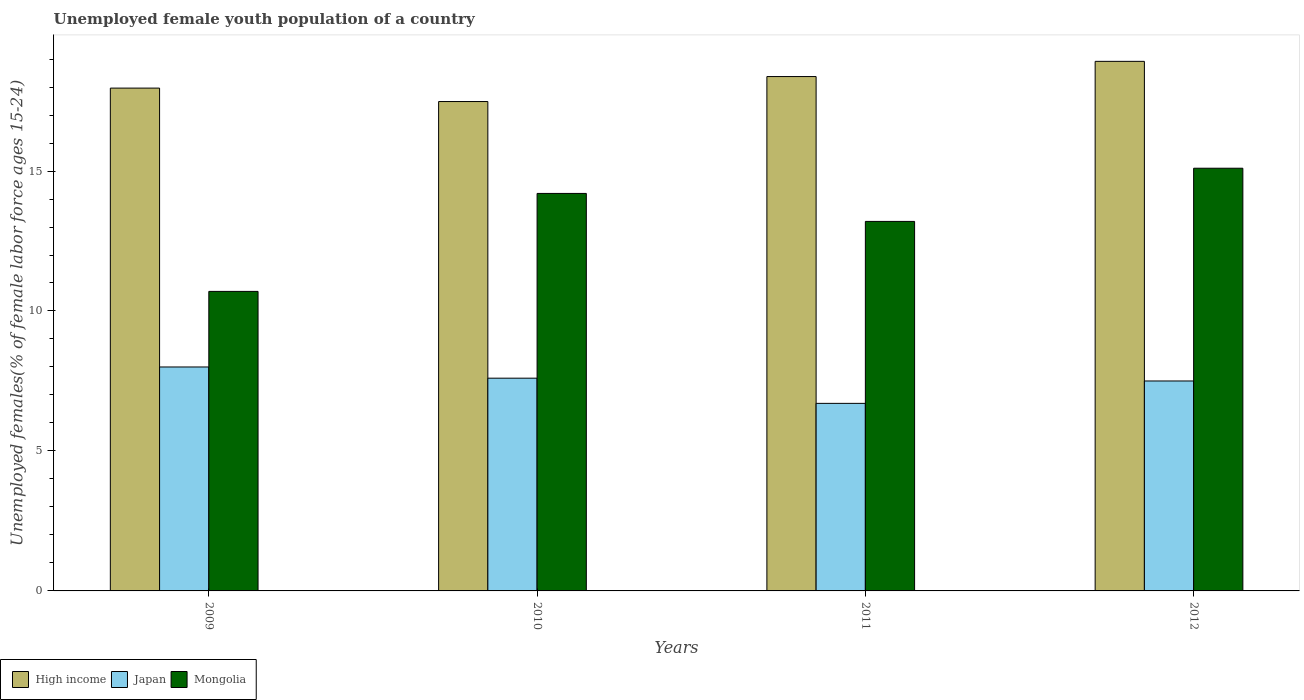How many different coloured bars are there?
Your answer should be very brief. 3. How many groups of bars are there?
Your answer should be compact. 4. Are the number of bars on each tick of the X-axis equal?
Give a very brief answer. Yes. How many bars are there on the 1st tick from the right?
Your answer should be compact. 3. In how many cases, is the number of bars for a given year not equal to the number of legend labels?
Give a very brief answer. 0. What is the percentage of unemployed female youth population in Mongolia in 2011?
Ensure brevity in your answer.  13.2. Across all years, what is the maximum percentage of unemployed female youth population in Japan?
Make the answer very short. 8. Across all years, what is the minimum percentage of unemployed female youth population in Japan?
Ensure brevity in your answer.  6.7. In which year was the percentage of unemployed female youth population in Japan maximum?
Offer a terse response. 2009. In which year was the percentage of unemployed female youth population in Mongolia minimum?
Offer a very short reply. 2009. What is the total percentage of unemployed female youth population in Mongolia in the graph?
Offer a very short reply. 53.2. What is the difference between the percentage of unemployed female youth population in Japan in 2010 and that in 2012?
Give a very brief answer. 0.1. What is the difference between the percentage of unemployed female youth population in High income in 2011 and the percentage of unemployed female youth population in Japan in 2009?
Ensure brevity in your answer.  10.38. What is the average percentage of unemployed female youth population in High income per year?
Offer a terse response. 18.18. In the year 2011, what is the difference between the percentage of unemployed female youth population in Japan and percentage of unemployed female youth population in Mongolia?
Your answer should be compact. -6.5. In how many years, is the percentage of unemployed female youth population in Japan greater than 18 %?
Make the answer very short. 0. What is the ratio of the percentage of unemployed female youth population in Mongolia in 2009 to that in 2010?
Give a very brief answer. 0.75. Is the percentage of unemployed female youth population in Mongolia in 2010 less than that in 2012?
Your response must be concise. Yes. What is the difference between the highest and the second highest percentage of unemployed female youth population in Japan?
Ensure brevity in your answer.  0.4. What is the difference between the highest and the lowest percentage of unemployed female youth population in Japan?
Keep it short and to the point. 1.3. Is the sum of the percentage of unemployed female youth population in High income in 2009 and 2011 greater than the maximum percentage of unemployed female youth population in Japan across all years?
Offer a terse response. Yes. What does the 1st bar from the right in 2011 represents?
Provide a succinct answer. Mongolia. Is it the case that in every year, the sum of the percentage of unemployed female youth population in Japan and percentage of unemployed female youth population in Mongolia is greater than the percentage of unemployed female youth population in High income?
Make the answer very short. Yes. Are all the bars in the graph horizontal?
Make the answer very short. No. How many legend labels are there?
Make the answer very short. 3. What is the title of the graph?
Give a very brief answer. Unemployed female youth population of a country. What is the label or title of the X-axis?
Offer a terse response. Years. What is the label or title of the Y-axis?
Your response must be concise. Unemployed females(% of female labor force ages 15-24). What is the Unemployed females(% of female labor force ages 15-24) of High income in 2009?
Ensure brevity in your answer.  17.96. What is the Unemployed females(% of female labor force ages 15-24) in Mongolia in 2009?
Offer a very short reply. 10.7. What is the Unemployed females(% of female labor force ages 15-24) of High income in 2010?
Your response must be concise. 17.48. What is the Unemployed females(% of female labor force ages 15-24) in Japan in 2010?
Your answer should be very brief. 7.6. What is the Unemployed females(% of female labor force ages 15-24) in Mongolia in 2010?
Offer a very short reply. 14.2. What is the Unemployed females(% of female labor force ages 15-24) of High income in 2011?
Provide a short and direct response. 18.38. What is the Unemployed females(% of female labor force ages 15-24) in Japan in 2011?
Your response must be concise. 6.7. What is the Unemployed females(% of female labor force ages 15-24) in Mongolia in 2011?
Ensure brevity in your answer.  13.2. What is the Unemployed females(% of female labor force ages 15-24) of High income in 2012?
Ensure brevity in your answer.  18.92. What is the Unemployed females(% of female labor force ages 15-24) in Japan in 2012?
Offer a very short reply. 7.5. What is the Unemployed females(% of female labor force ages 15-24) of Mongolia in 2012?
Your answer should be very brief. 15.1. Across all years, what is the maximum Unemployed females(% of female labor force ages 15-24) of High income?
Make the answer very short. 18.92. Across all years, what is the maximum Unemployed females(% of female labor force ages 15-24) in Mongolia?
Give a very brief answer. 15.1. Across all years, what is the minimum Unemployed females(% of female labor force ages 15-24) in High income?
Keep it short and to the point. 17.48. Across all years, what is the minimum Unemployed females(% of female labor force ages 15-24) of Japan?
Your response must be concise. 6.7. Across all years, what is the minimum Unemployed females(% of female labor force ages 15-24) in Mongolia?
Your answer should be compact. 10.7. What is the total Unemployed females(% of female labor force ages 15-24) in High income in the graph?
Provide a succinct answer. 72.74. What is the total Unemployed females(% of female labor force ages 15-24) of Japan in the graph?
Offer a very short reply. 29.8. What is the total Unemployed females(% of female labor force ages 15-24) of Mongolia in the graph?
Your answer should be compact. 53.2. What is the difference between the Unemployed females(% of female labor force ages 15-24) of High income in 2009 and that in 2010?
Your answer should be very brief. 0.48. What is the difference between the Unemployed females(% of female labor force ages 15-24) of Mongolia in 2009 and that in 2010?
Provide a short and direct response. -3.5. What is the difference between the Unemployed females(% of female labor force ages 15-24) of High income in 2009 and that in 2011?
Your answer should be compact. -0.41. What is the difference between the Unemployed females(% of female labor force ages 15-24) of High income in 2009 and that in 2012?
Your answer should be compact. -0.96. What is the difference between the Unemployed females(% of female labor force ages 15-24) in Japan in 2009 and that in 2012?
Give a very brief answer. 0.5. What is the difference between the Unemployed females(% of female labor force ages 15-24) of Mongolia in 2009 and that in 2012?
Provide a short and direct response. -4.4. What is the difference between the Unemployed females(% of female labor force ages 15-24) of High income in 2010 and that in 2011?
Your answer should be very brief. -0.89. What is the difference between the Unemployed females(% of female labor force ages 15-24) in Japan in 2010 and that in 2011?
Your answer should be very brief. 0.9. What is the difference between the Unemployed females(% of female labor force ages 15-24) of High income in 2010 and that in 2012?
Offer a terse response. -1.44. What is the difference between the Unemployed females(% of female labor force ages 15-24) of Mongolia in 2010 and that in 2012?
Make the answer very short. -0.9. What is the difference between the Unemployed females(% of female labor force ages 15-24) in High income in 2011 and that in 2012?
Provide a short and direct response. -0.54. What is the difference between the Unemployed females(% of female labor force ages 15-24) in Mongolia in 2011 and that in 2012?
Keep it short and to the point. -1.9. What is the difference between the Unemployed females(% of female labor force ages 15-24) of High income in 2009 and the Unemployed females(% of female labor force ages 15-24) of Japan in 2010?
Your answer should be compact. 10.36. What is the difference between the Unemployed females(% of female labor force ages 15-24) of High income in 2009 and the Unemployed females(% of female labor force ages 15-24) of Mongolia in 2010?
Ensure brevity in your answer.  3.76. What is the difference between the Unemployed females(% of female labor force ages 15-24) of Japan in 2009 and the Unemployed females(% of female labor force ages 15-24) of Mongolia in 2010?
Provide a short and direct response. -6.2. What is the difference between the Unemployed females(% of female labor force ages 15-24) of High income in 2009 and the Unemployed females(% of female labor force ages 15-24) of Japan in 2011?
Keep it short and to the point. 11.26. What is the difference between the Unemployed females(% of female labor force ages 15-24) in High income in 2009 and the Unemployed females(% of female labor force ages 15-24) in Mongolia in 2011?
Provide a short and direct response. 4.76. What is the difference between the Unemployed females(% of female labor force ages 15-24) in Japan in 2009 and the Unemployed females(% of female labor force ages 15-24) in Mongolia in 2011?
Keep it short and to the point. -5.2. What is the difference between the Unemployed females(% of female labor force ages 15-24) in High income in 2009 and the Unemployed females(% of female labor force ages 15-24) in Japan in 2012?
Give a very brief answer. 10.46. What is the difference between the Unemployed females(% of female labor force ages 15-24) in High income in 2009 and the Unemployed females(% of female labor force ages 15-24) in Mongolia in 2012?
Your answer should be compact. 2.86. What is the difference between the Unemployed females(% of female labor force ages 15-24) of High income in 2010 and the Unemployed females(% of female labor force ages 15-24) of Japan in 2011?
Give a very brief answer. 10.78. What is the difference between the Unemployed females(% of female labor force ages 15-24) of High income in 2010 and the Unemployed females(% of female labor force ages 15-24) of Mongolia in 2011?
Ensure brevity in your answer.  4.28. What is the difference between the Unemployed females(% of female labor force ages 15-24) of Japan in 2010 and the Unemployed females(% of female labor force ages 15-24) of Mongolia in 2011?
Provide a short and direct response. -5.6. What is the difference between the Unemployed females(% of female labor force ages 15-24) in High income in 2010 and the Unemployed females(% of female labor force ages 15-24) in Japan in 2012?
Your response must be concise. 9.98. What is the difference between the Unemployed females(% of female labor force ages 15-24) of High income in 2010 and the Unemployed females(% of female labor force ages 15-24) of Mongolia in 2012?
Your response must be concise. 2.38. What is the difference between the Unemployed females(% of female labor force ages 15-24) of High income in 2011 and the Unemployed females(% of female labor force ages 15-24) of Japan in 2012?
Your response must be concise. 10.88. What is the difference between the Unemployed females(% of female labor force ages 15-24) of High income in 2011 and the Unemployed females(% of female labor force ages 15-24) of Mongolia in 2012?
Offer a terse response. 3.28. What is the difference between the Unemployed females(% of female labor force ages 15-24) in Japan in 2011 and the Unemployed females(% of female labor force ages 15-24) in Mongolia in 2012?
Give a very brief answer. -8.4. What is the average Unemployed females(% of female labor force ages 15-24) of High income per year?
Keep it short and to the point. 18.18. What is the average Unemployed females(% of female labor force ages 15-24) of Japan per year?
Make the answer very short. 7.45. What is the average Unemployed females(% of female labor force ages 15-24) in Mongolia per year?
Offer a very short reply. 13.3. In the year 2009, what is the difference between the Unemployed females(% of female labor force ages 15-24) in High income and Unemployed females(% of female labor force ages 15-24) in Japan?
Provide a short and direct response. 9.96. In the year 2009, what is the difference between the Unemployed females(% of female labor force ages 15-24) of High income and Unemployed females(% of female labor force ages 15-24) of Mongolia?
Keep it short and to the point. 7.26. In the year 2009, what is the difference between the Unemployed females(% of female labor force ages 15-24) of Japan and Unemployed females(% of female labor force ages 15-24) of Mongolia?
Your answer should be compact. -2.7. In the year 2010, what is the difference between the Unemployed females(% of female labor force ages 15-24) in High income and Unemployed females(% of female labor force ages 15-24) in Japan?
Offer a terse response. 9.88. In the year 2010, what is the difference between the Unemployed females(% of female labor force ages 15-24) of High income and Unemployed females(% of female labor force ages 15-24) of Mongolia?
Ensure brevity in your answer.  3.28. In the year 2010, what is the difference between the Unemployed females(% of female labor force ages 15-24) of Japan and Unemployed females(% of female labor force ages 15-24) of Mongolia?
Offer a very short reply. -6.6. In the year 2011, what is the difference between the Unemployed females(% of female labor force ages 15-24) in High income and Unemployed females(% of female labor force ages 15-24) in Japan?
Your answer should be very brief. 11.68. In the year 2011, what is the difference between the Unemployed females(% of female labor force ages 15-24) of High income and Unemployed females(% of female labor force ages 15-24) of Mongolia?
Provide a short and direct response. 5.18. In the year 2012, what is the difference between the Unemployed females(% of female labor force ages 15-24) of High income and Unemployed females(% of female labor force ages 15-24) of Japan?
Keep it short and to the point. 11.42. In the year 2012, what is the difference between the Unemployed females(% of female labor force ages 15-24) of High income and Unemployed females(% of female labor force ages 15-24) of Mongolia?
Your answer should be compact. 3.82. In the year 2012, what is the difference between the Unemployed females(% of female labor force ages 15-24) in Japan and Unemployed females(% of female labor force ages 15-24) in Mongolia?
Provide a succinct answer. -7.6. What is the ratio of the Unemployed females(% of female labor force ages 15-24) in High income in 2009 to that in 2010?
Offer a terse response. 1.03. What is the ratio of the Unemployed females(% of female labor force ages 15-24) in Japan in 2009 to that in 2010?
Provide a succinct answer. 1.05. What is the ratio of the Unemployed females(% of female labor force ages 15-24) in Mongolia in 2009 to that in 2010?
Offer a very short reply. 0.75. What is the ratio of the Unemployed females(% of female labor force ages 15-24) of High income in 2009 to that in 2011?
Your answer should be compact. 0.98. What is the ratio of the Unemployed females(% of female labor force ages 15-24) in Japan in 2009 to that in 2011?
Offer a terse response. 1.19. What is the ratio of the Unemployed females(% of female labor force ages 15-24) of Mongolia in 2009 to that in 2011?
Offer a very short reply. 0.81. What is the ratio of the Unemployed females(% of female labor force ages 15-24) of High income in 2009 to that in 2012?
Your answer should be compact. 0.95. What is the ratio of the Unemployed females(% of female labor force ages 15-24) in Japan in 2009 to that in 2012?
Provide a short and direct response. 1.07. What is the ratio of the Unemployed females(% of female labor force ages 15-24) in Mongolia in 2009 to that in 2012?
Your answer should be very brief. 0.71. What is the ratio of the Unemployed females(% of female labor force ages 15-24) in High income in 2010 to that in 2011?
Offer a terse response. 0.95. What is the ratio of the Unemployed females(% of female labor force ages 15-24) in Japan in 2010 to that in 2011?
Provide a short and direct response. 1.13. What is the ratio of the Unemployed females(% of female labor force ages 15-24) in Mongolia in 2010 to that in 2011?
Your answer should be very brief. 1.08. What is the ratio of the Unemployed females(% of female labor force ages 15-24) in High income in 2010 to that in 2012?
Your answer should be very brief. 0.92. What is the ratio of the Unemployed females(% of female labor force ages 15-24) of Japan in 2010 to that in 2012?
Your answer should be compact. 1.01. What is the ratio of the Unemployed females(% of female labor force ages 15-24) in Mongolia in 2010 to that in 2012?
Keep it short and to the point. 0.94. What is the ratio of the Unemployed females(% of female labor force ages 15-24) of High income in 2011 to that in 2012?
Your answer should be very brief. 0.97. What is the ratio of the Unemployed females(% of female labor force ages 15-24) of Japan in 2011 to that in 2012?
Provide a succinct answer. 0.89. What is the ratio of the Unemployed females(% of female labor force ages 15-24) of Mongolia in 2011 to that in 2012?
Provide a succinct answer. 0.87. What is the difference between the highest and the second highest Unemployed females(% of female labor force ages 15-24) in High income?
Provide a short and direct response. 0.54. What is the difference between the highest and the second highest Unemployed females(% of female labor force ages 15-24) of Mongolia?
Provide a short and direct response. 0.9. What is the difference between the highest and the lowest Unemployed females(% of female labor force ages 15-24) of High income?
Offer a very short reply. 1.44. 